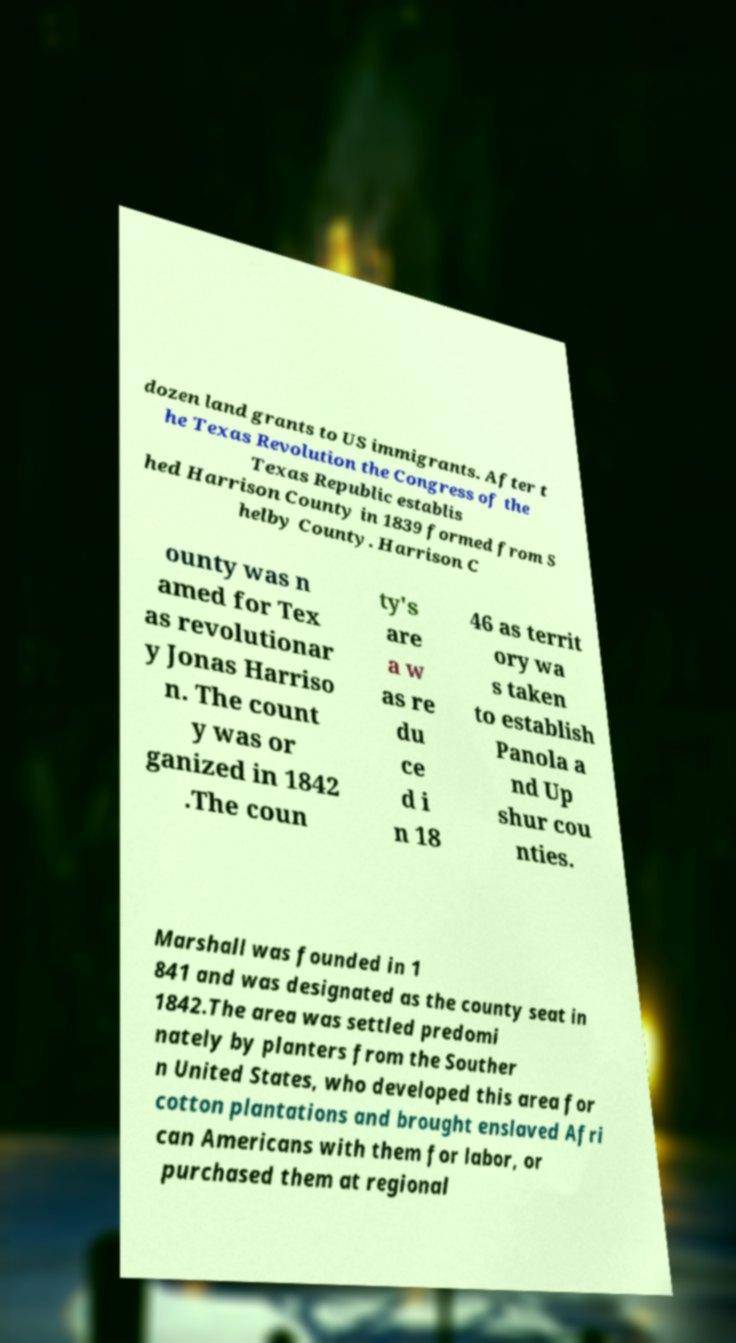Could you extract and type out the text from this image? dozen land grants to US immigrants. After t he Texas Revolution the Congress of the Texas Republic establis hed Harrison County in 1839 formed from S helby County. Harrison C ounty was n amed for Tex as revolutionar y Jonas Harriso n. The count y was or ganized in 1842 .The coun ty's are a w as re du ce d i n 18 46 as territ ory wa s taken to establish Panola a nd Up shur cou nties. Marshall was founded in 1 841 and was designated as the county seat in 1842.The area was settled predomi nately by planters from the Souther n United States, who developed this area for cotton plantations and brought enslaved Afri can Americans with them for labor, or purchased them at regional 